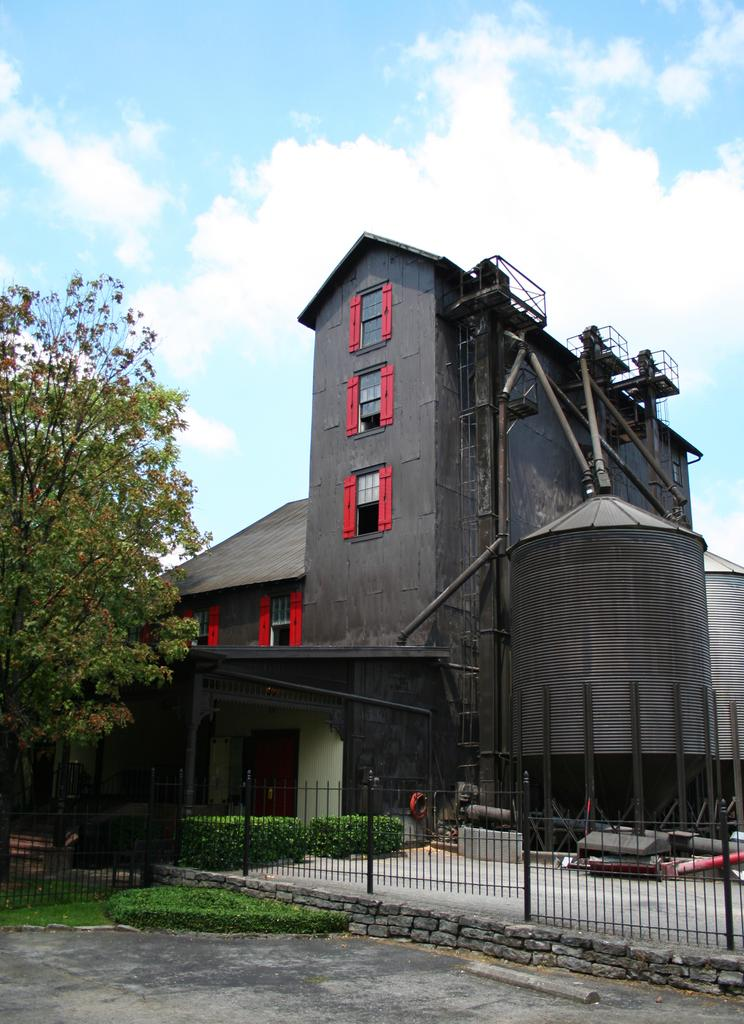What type of natural element is present in the image? There is a tree in the image. What structure is located near the tree? There is a building beside the tree. What type of barrier surrounds the building? There is fencing around the building. What type of surface is in front of the fencing? There is a pavement in front of the fencing? How many oranges are hanging from the tree in the image? There are no oranges present in the image; it features a tree and a building. Can you describe the industry that is depicted in the image? There is no industry depicted in the image; it features a tree, a building, fencing, and a pavement. 